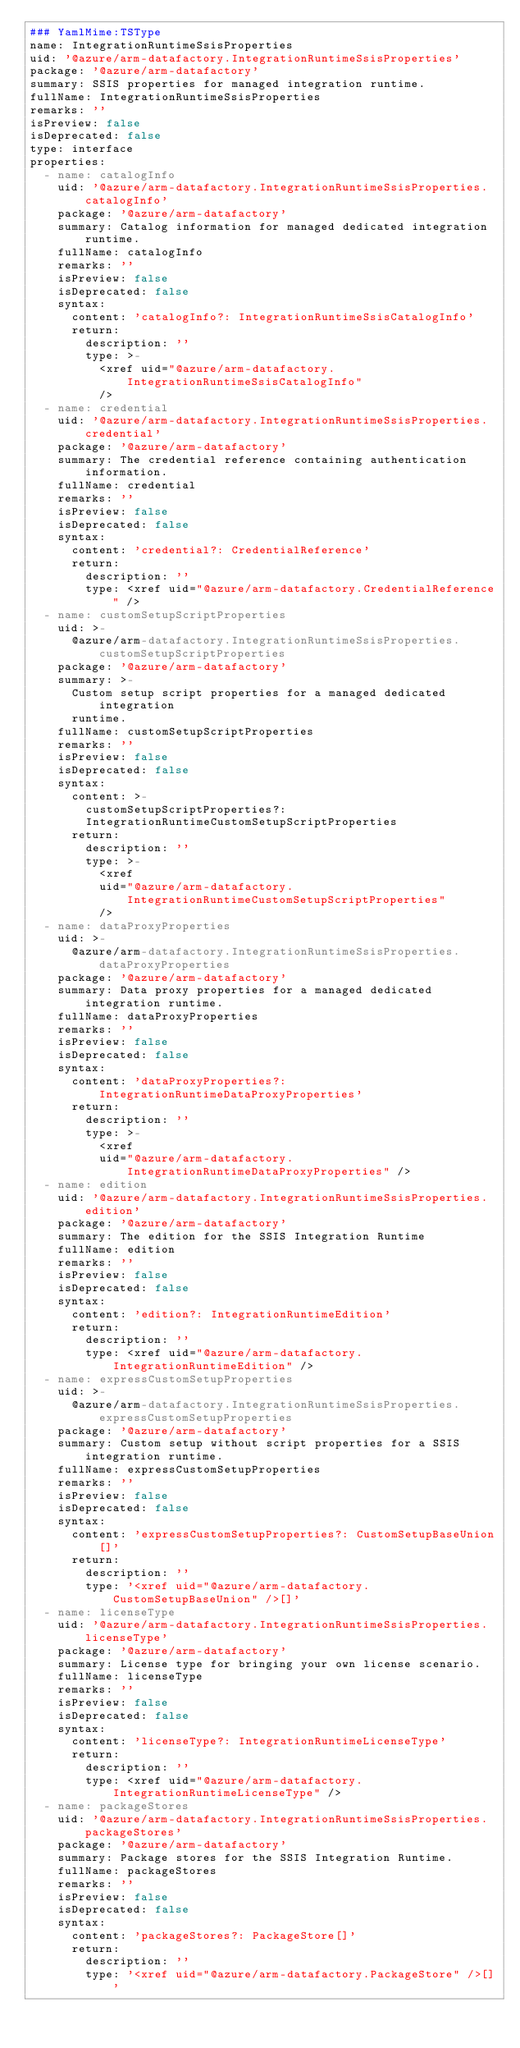<code> <loc_0><loc_0><loc_500><loc_500><_YAML_>### YamlMime:TSType
name: IntegrationRuntimeSsisProperties
uid: '@azure/arm-datafactory.IntegrationRuntimeSsisProperties'
package: '@azure/arm-datafactory'
summary: SSIS properties for managed integration runtime.
fullName: IntegrationRuntimeSsisProperties
remarks: ''
isPreview: false
isDeprecated: false
type: interface
properties:
  - name: catalogInfo
    uid: '@azure/arm-datafactory.IntegrationRuntimeSsisProperties.catalogInfo'
    package: '@azure/arm-datafactory'
    summary: Catalog information for managed dedicated integration runtime.
    fullName: catalogInfo
    remarks: ''
    isPreview: false
    isDeprecated: false
    syntax:
      content: 'catalogInfo?: IntegrationRuntimeSsisCatalogInfo'
      return:
        description: ''
        type: >-
          <xref uid="@azure/arm-datafactory.IntegrationRuntimeSsisCatalogInfo"
          />
  - name: credential
    uid: '@azure/arm-datafactory.IntegrationRuntimeSsisProperties.credential'
    package: '@azure/arm-datafactory'
    summary: The credential reference containing authentication information.
    fullName: credential
    remarks: ''
    isPreview: false
    isDeprecated: false
    syntax:
      content: 'credential?: CredentialReference'
      return:
        description: ''
        type: <xref uid="@azure/arm-datafactory.CredentialReference" />
  - name: customSetupScriptProperties
    uid: >-
      @azure/arm-datafactory.IntegrationRuntimeSsisProperties.customSetupScriptProperties
    package: '@azure/arm-datafactory'
    summary: >-
      Custom setup script properties for a managed dedicated integration
      runtime.
    fullName: customSetupScriptProperties
    remarks: ''
    isPreview: false
    isDeprecated: false
    syntax:
      content: >-
        customSetupScriptProperties?:
        IntegrationRuntimeCustomSetupScriptProperties
      return:
        description: ''
        type: >-
          <xref
          uid="@azure/arm-datafactory.IntegrationRuntimeCustomSetupScriptProperties"
          />
  - name: dataProxyProperties
    uid: >-
      @azure/arm-datafactory.IntegrationRuntimeSsisProperties.dataProxyProperties
    package: '@azure/arm-datafactory'
    summary: Data proxy properties for a managed dedicated integration runtime.
    fullName: dataProxyProperties
    remarks: ''
    isPreview: false
    isDeprecated: false
    syntax:
      content: 'dataProxyProperties?: IntegrationRuntimeDataProxyProperties'
      return:
        description: ''
        type: >-
          <xref
          uid="@azure/arm-datafactory.IntegrationRuntimeDataProxyProperties" />
  - name: edition
    uid: '@azure/arm-datafactory.IntegrationRuntimeSsisProperties.edition'
    package: '@azure/arm-datafactory'
    summary: The edition for the SSIS Integration Runtime
    fullName: edition
    remarks: ''
    isPreview: false
    isDeprecated: false
    syntax:
      content: 'edition?: IntegrationRuntimeEdition'
      return:
        description: ''
        type: <xref uid="@azure/arm-datafactory.IntegrationRuntimeEdition" />
  - name: expressCustomSetupProperties
    uid: >-
      @azure/arm-datafactory.IntegrationRuntimeSsisProperties.expressCustomSetupProperties
    package: '@azure/arm-datafactory'
    summary: Custom setup without script properties for a SSIS integration runtime.
    fullName: expressCustomSetupProperties
    remarks: ''
    isPreview: false
    isDeprecated: false
    syntax:
      content: 'expressCustomSetupProperties?: CustomSetupBaseUnion[]'
      return:
        description: ''
        type: '<xref uid="@azure/arm-datafactory.CustomSetupBaseUnion" />[]'
  - name: licenseType
    uid: '@azure/arm-datafactory.IntegrationRuntimeSsisProperties.licenseType'
    package: '@azure/arm-datafactory'
    summary: License type for bringing your own license scenario.
    fullName: licenseType
    remarks: ''
    isPreview: false
    isDeprecated: false
    syntax:
      content: 'licenseType?: IntegrationRuntimeLicenseType'
      return:
        description: ''
        type: <xref uid="@azure/arm-datafactory.IntegrationRuntimeLicenseType" />
  - name: packageStores
    uid: '@azure/arm-datafactory.IntegrationRuntimeSsisProperties.packageStores'
    package: '@azure/arm-datafactory'
    summary: Package stores for the SSIS Integration Runtime.
    fullName: packageStores
    remarks: ''
    isPreview: false
    isDeprecated: false
    syntax:
      content: 'packageStores?: PackageStore[]'
      return:
        description: ''
        type: '<xref uid="@azure/arm-datafactory.PackageStore" />[]'
</code> 